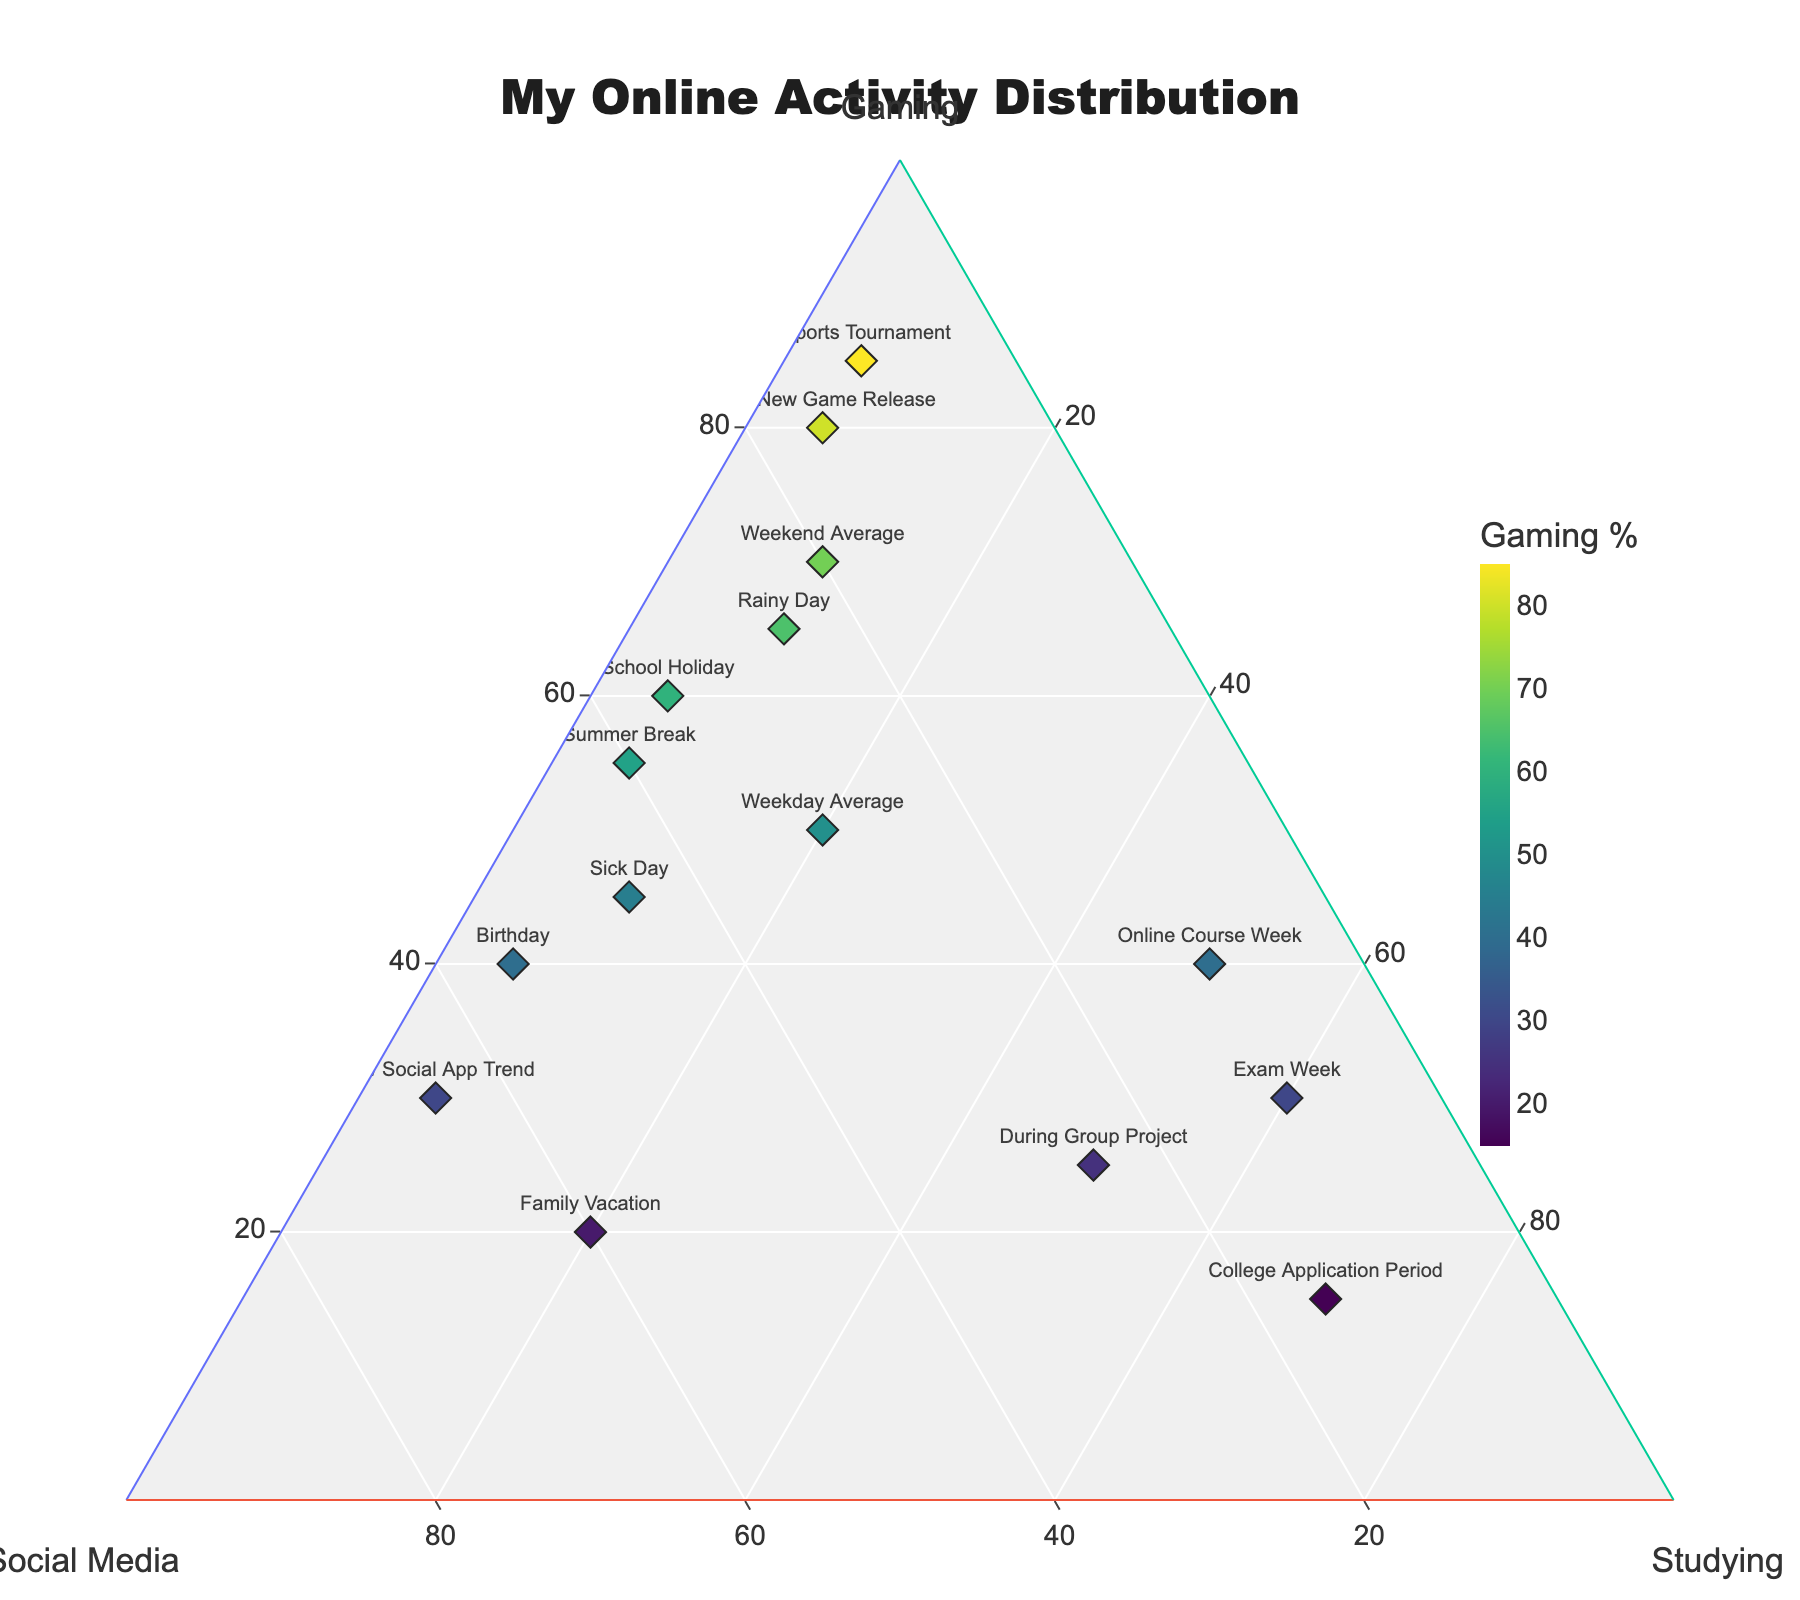What activity takes up the most time on school holidays? Look for the data point labeled "School Holiday." The point shows 60% gaming, 35% social media, and 5% studying. The highest percentage is gaming.
Answer: Gaming Which activity is prioritized during an exam week? Find the data point labeled "Exam Week." The figures are 30% gaming, 10% social media, and 60% studying. The highest percentage is studying.
Answer: Studying How does the time spent on gaming during a family vacation compare to studying? Look for the data point labeled "Family Vacation," which shows 20% gaming and 20% studying. Both have the same percentage, indicating equal time spent.
Answer: Equal Which scenario has the highest percentage of social media use? Identify the data point with the highest social media percentage. The "New Social App Trend" shows 65% social media use.
Answer: New Social App Trend What is the total percentage of time spent on studying and gaming during a birthday? Find the data point labeled "Birthday." It shows 40% gaming and 5% studying. Add these two values: 40% + 5% = 45%.
Answer: 45% Compare the time spent on social media during the summer break and during a rainy day. Locate "Summer Break" (40% social media) and "Rainy Day" (25% social media). Summer Break has more social media time.
Answer: Summer Break During which scenario is gaming least prominent? Find the data point with the lowest gaming percentage. The "College Application Period" shows 15% gaming.
Answer: College Application Period What is the range of percentage values for studying across all scenarios? Identify the maximum and minimum values for studying: Maximum is 70% (College Application Period), and minimum is 5% (School Holiday, Summer Break, After New Game Release, Birthday, New Social App Trend, Esports Tournament). The range is 70% - 5% = 65%.
Answer: 65% In which scenario is the distribution of activities most balanced? Look for the data point with nearly equal values across all activities. "Sick Day" has 45% gaming, 45% social media, and 10% studying, making it relatively balanced.
Answer: Sick Day During the "Esports Tournament," what percentage of time is not spent on gaming? The "Esports Tournament" shows 85% gaming. The remaining time not spent on gaming is 100% - 85% = 15%.
Answer: 15% 